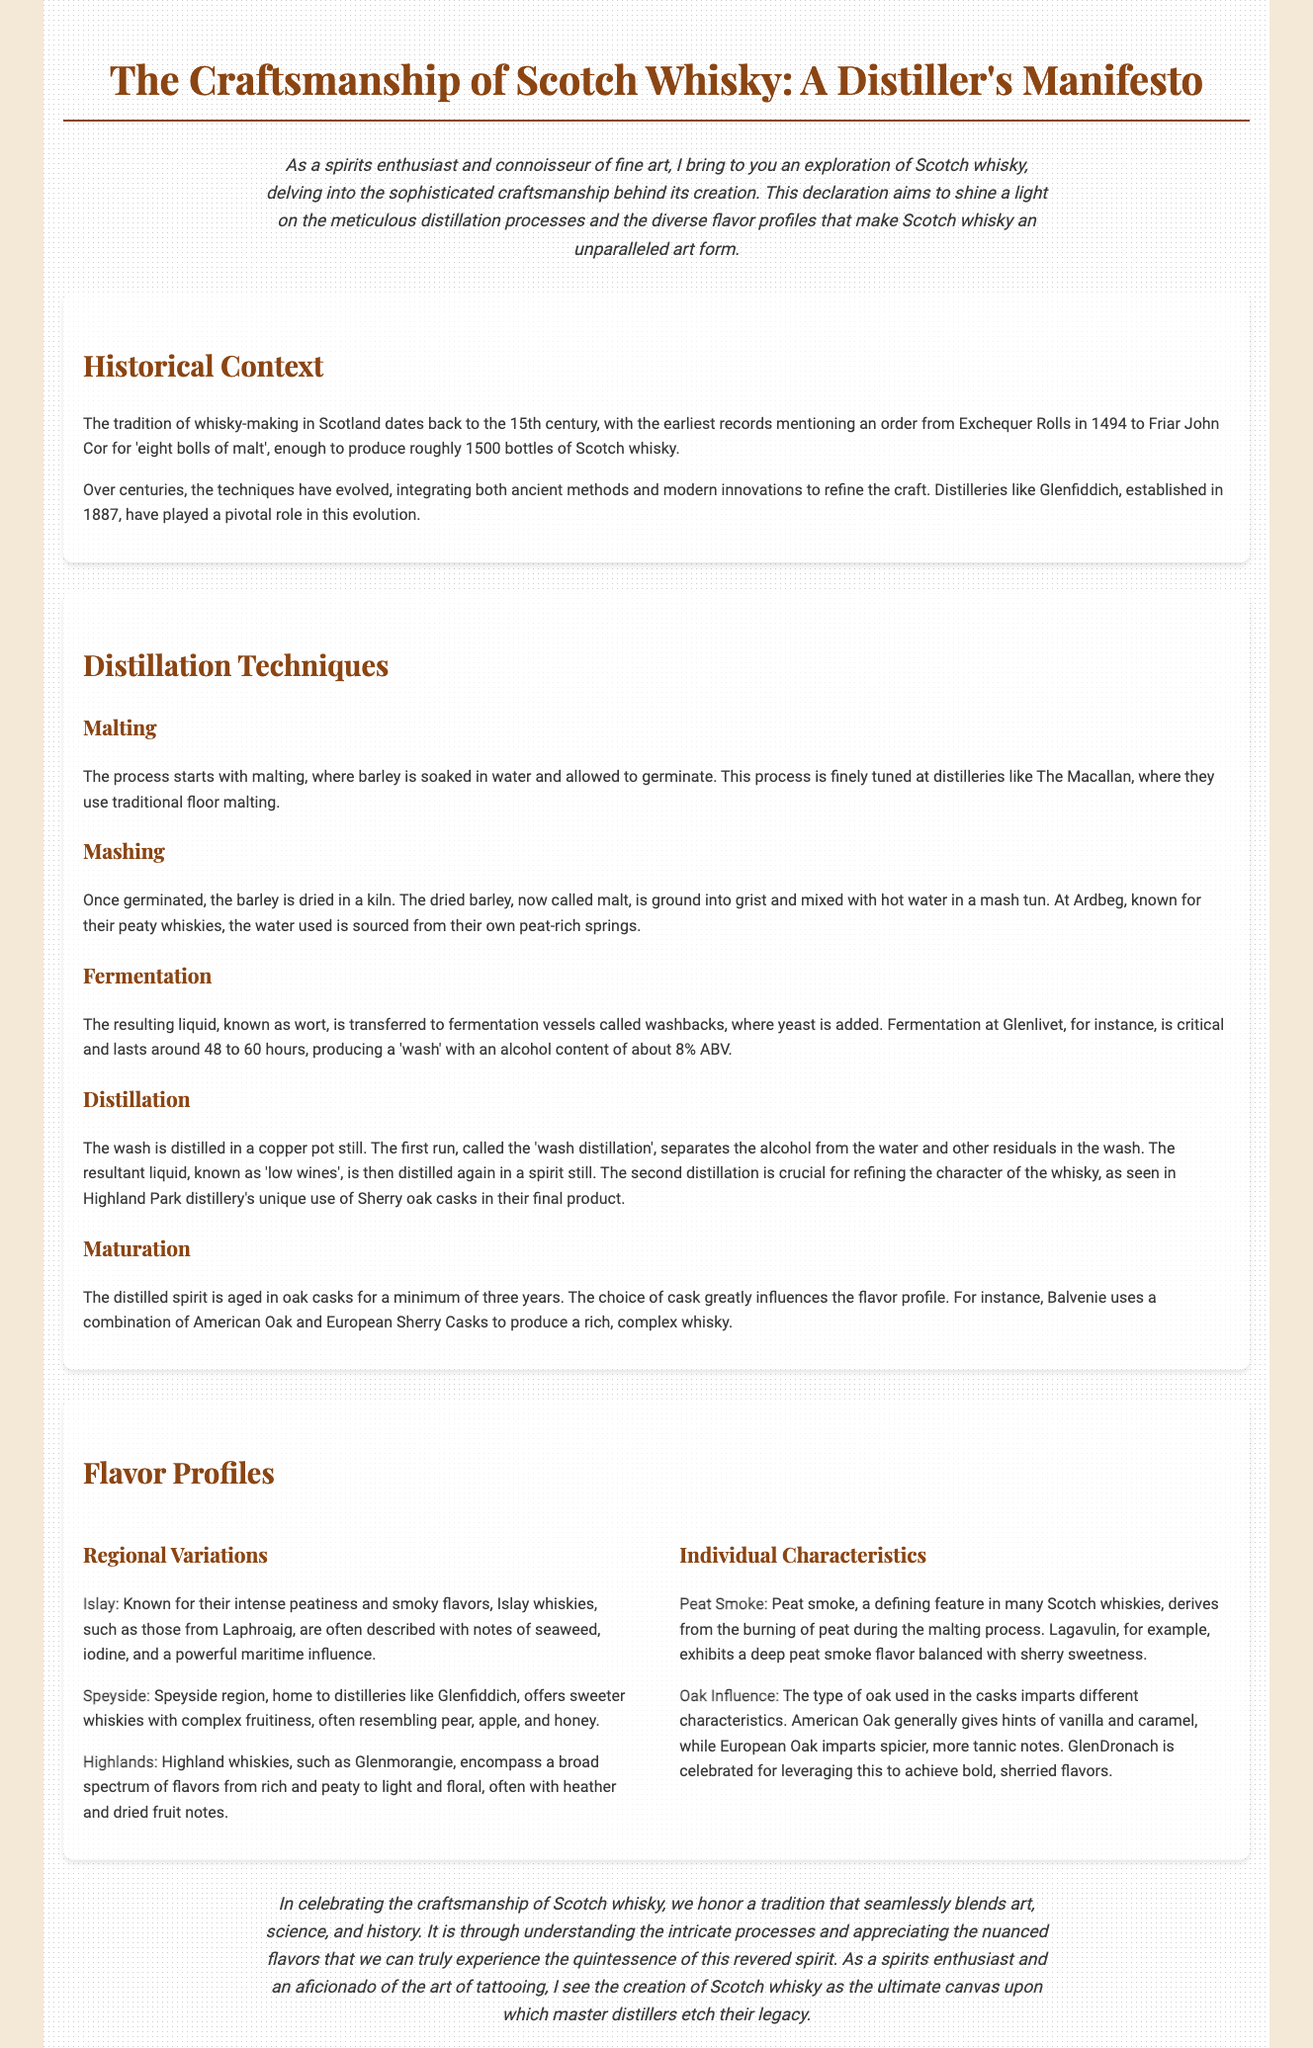What year did whisky-making in Scotland begin? The document states that whisky-making in Scotland dates back to the 15th century, specifically mentioning an order in 1494.
Answer: 1494 Which distillery is known for traditional floor malting? The distillation techniques section points out that The Macallan is recognized for its traditional floor malting.
Answer: The Macallan What is the minimum aging period for distilled spirits? The maturation section indicates that the distilled spirit is aged in oak casks for a minimum of three years.
Answer: Three years Which region is known for intense peatiness and smoky flavors? The flavor profile section highlights that Islay whiskies are known for their intense peatiness and smoky characteristics.
Answer: Islay What type of oak is celebrated for producing bold, sherried flavors? In discussing oak influence, the document mentions that GlenDronach is celebrated for leveraging European Oak to achieve bold, sherried flavors.
Answer: European Oak How long does fermentation last at Glenlivet? The text specifies that fermentation at Glenlivet lasts around 48 to 60 hours.
Answer: 48 to 60 hours What flavor notes are associated with Speyside whiskies? The flavor profile section describes that Speyside whiskies offer sweeter whiskies with complex fruitiness, resembling pear, apple, and honey.
Answer: Pear, apple, and honey What is the first distillation run called? The document refers to the first run of distillation as the 'wash distillation'.
Answer: Wash distillation What is the primary role of malt in the whisky-making process? The malting process is crucial as it refers to barley being soaked and germinated to produce malt.
Answer: Produce malt 